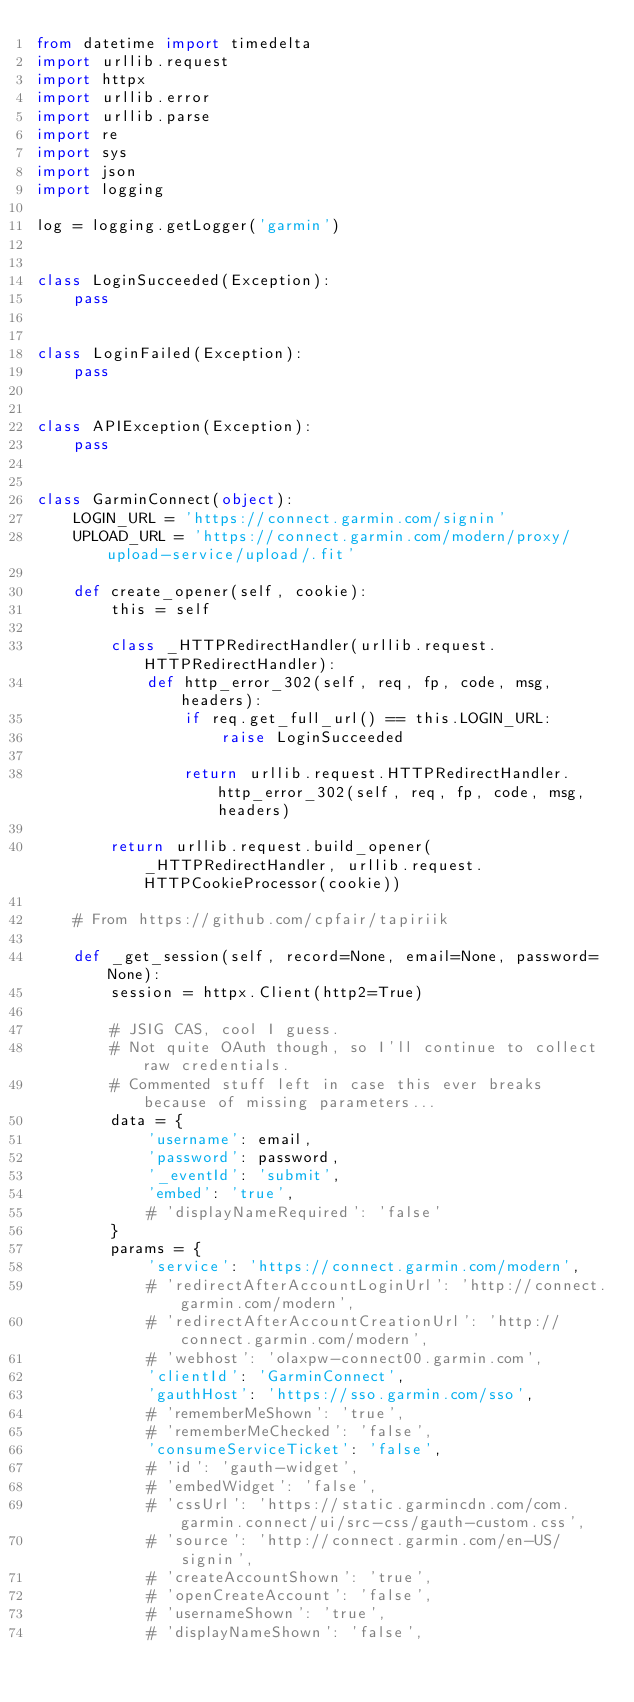Convert code to text. <code><loc_0><loc_0><loc_500><loc_500><_Python_>from datetime import timedelta
import urllib.request
import httpx
import urllib.error
import urllib.parse
import re
import sys
import json
import logging

log = logging.getLogger('garmin')


class LoginSucceeded(Exception):
    pass


class LoginFailed(Exception):
    pass


class APIException(Exception):
    pass


class GarminConnect(object):
    LOGIN_URL = 'https://connect.garmin.com/signin'
    UPLOAD_URL = 'https://connect.garmin.com/modern/proxy/upload-service/upload/.fit'

    def create_opener(self, cookie):
        this = self

        class _HTTPRedirectHandler(urllib.request.HTTPRedirectHandler):
            def http_error_302(self, req, fp, code, msg, headers):
                if req.get_full_url() == this.LOGIN_URL:
                    raise LoginSucceeded

                return urllib.request.HTTPRedirectHandler.http_error_302(self, req, fp, code, msg, headers)

        return urllib.request.build_opener(_HTTPRedirectHandler, urllib.request.HTTPCookieProcessor(cookie))

    # From https://github.com/cpfair/tapiriik

    def _get_session(self, record=None, email=None, password=None):
        session = httpx.Client(http2=True)

        # JSIG CAS, cool I guess.
        # Not quite OAuth though, so I'll continue to collect raw credentials.
        # Commented stuff left in case this ever breaks because of missing parameters...
        data = {
            'username': email,
            'password': password,
            '_eventId': 'submit',
            'embed': 'true',
            # 'displayNameRequired': 'false'
        }
        params = {
            'service': 'https://connect.garmin.com/modern',
            # 'redirectAfterAccountLoginUrl': 'http://connect.garmin.com/modern',
            # 'redirectAfterAccountCreationUrl': 'http://connect.garmin.com/modern',
            # 'webhost': 'olaxpw-connect00.garmin.com',
            'clientId': 'GarminConnect',
            'gauthHost': 'https://sso.garmin.com/sso',
            # 'rememberMeShown': 'true',
            # 'rememberMeChecked': 'false',
            'consumeServiceTicket': 'false',
            # 'id': 'gauth-widget',
            # 'embedWidget': 'false',
            # 'cssUrl': 'https://static.garmincdn.com/com.garmin.connect/ui/src-css/gauth-custom.css',
            # 'source': 'http://connect.garmin.com/en-US/signin',
            # 'createAccountShown': 'true',
            # 'openCreateAccount': 'false',
            # 'usernameShown': 'true',
            # 'displayNameShown': 'false',</code> 